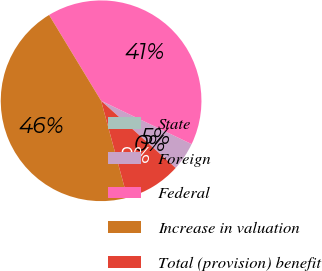<chart> <loc_0><loc_0><loc_500><loc_500><pie_chart><fcel>State<fcel>Foreign<fcel>Federal<fcel>Increase in valuation<fcel>Total (provision) benefit<nl><fcel>0.01%<fcel>4.56%<fcel>40.78%<fcel>45.53%<fcel>9.12%<nl></chart> 